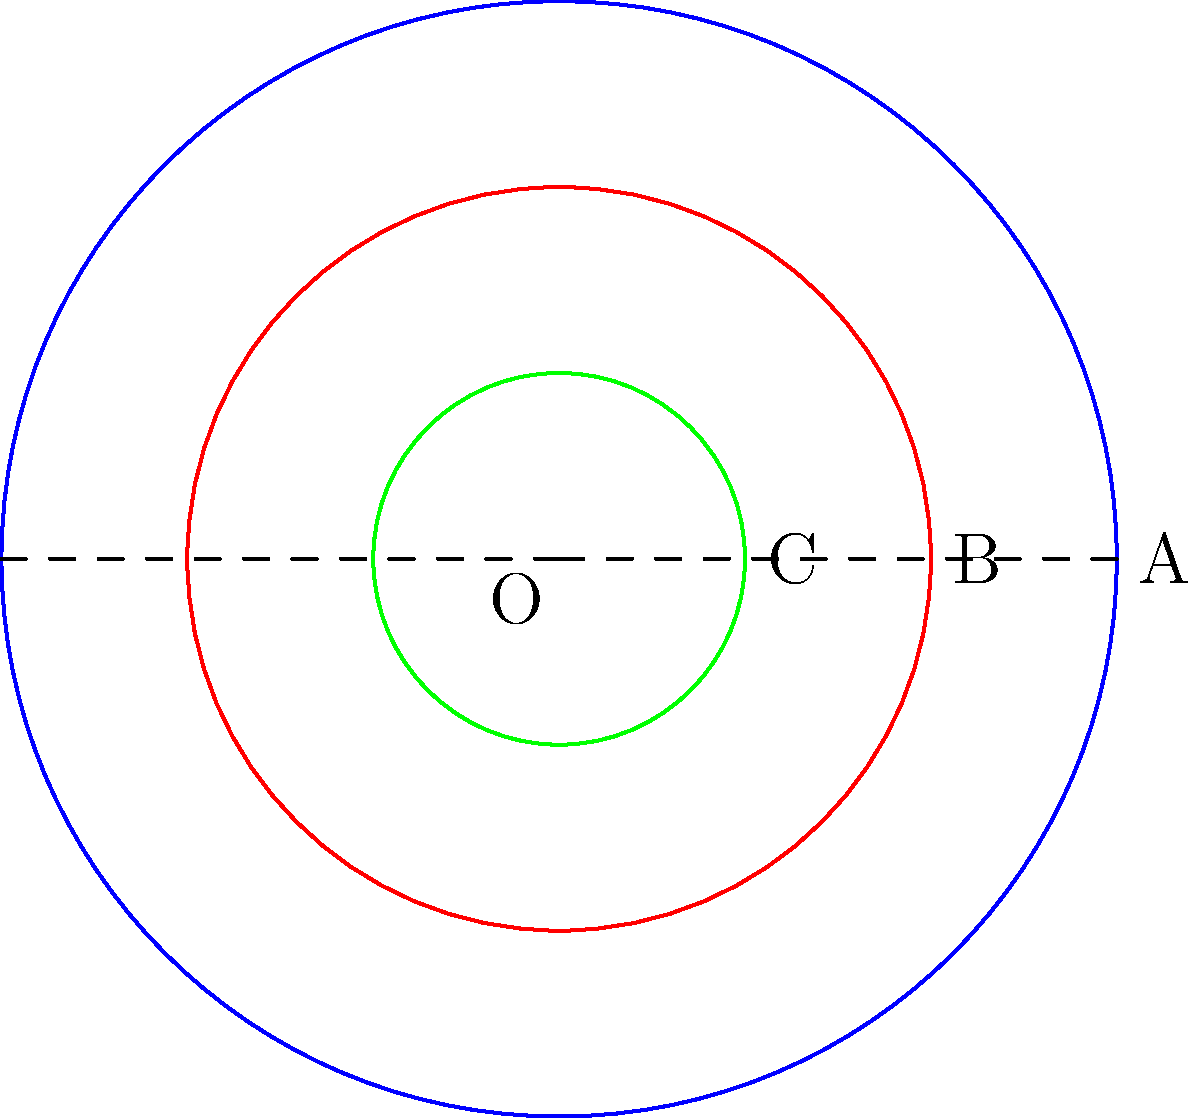In a recently excavated Mayan temple, archaeologists discovered a circular altar with three concentric rings. The outermost ring has a radius of 6 meters, the middle ring has a radius of 4 meters, and the innermost ring has a radius of 2 meters. If these rings represent the three levels of the Mayan cosmos (heavens, earth, and underworld), what is the ratio of the area of the middle ring (representing earth) to the area of the entire altar? Let's approach this step-by-step:

1) First, we need to calculate the areas of each circular region:

   Outermost circle (A): $$A_A = \pi r_A^2 = \pi (6^2) = 36\pi$$
   Middle circle (B): $$A_B = \pi r_B^2 = \pi (4^2) = 16\pi$$
   Innermost circle (C): $$A_C = \pi r_C^2 = \pi (2^2) = 4\pi$$

2) The middle ring represents the area between circles B and C:
   $$A_{middle ring} = A_B - A_C = 16\pi - 4\pi = 12\pi$$

3) The area of the entire altar is the area of the outermost circle (A):
   $$A_{total} = A_A = 36\pi$$

4) Now, we can calculate the ratio of the middle ring's area to the total area:

   $$\text{Ratio} = \frac{A_{middle ring}}{A_{total}} = \frac{12\pi}{36\pi} = \frac{12}{36} = \frac{1}{3}$$

5) This ratio can be interpreted in the context of Mayan cosmology, where the earth (represented by the middle ring) occupies one-third of the total cosmic space.
Answer: $\frac{1}{3}$ 